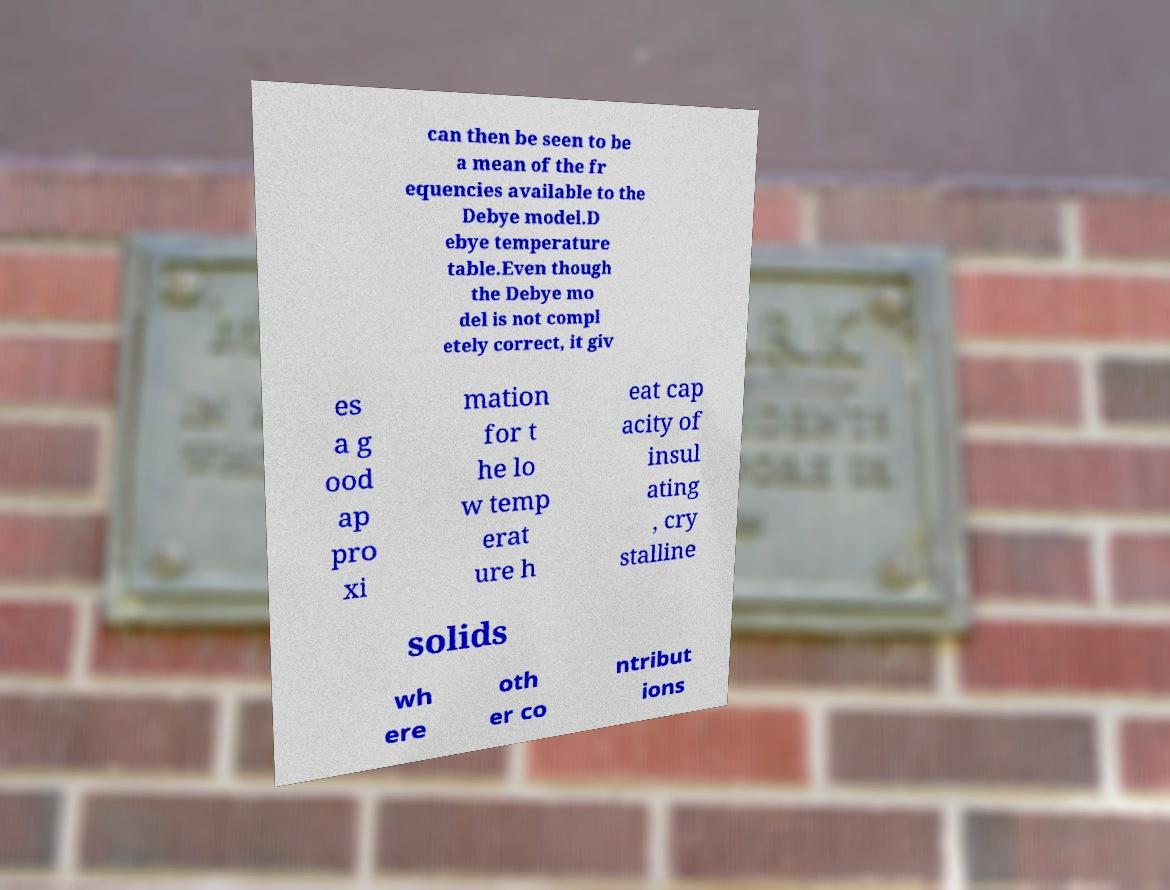For documentation purposes, I need the text within this image transcribed. Could you provide that? can then be seen to be a mean of the fr equencies available to the Debye model.D ebye temperature table.Even though the Debye mo del is not compl etely correct, it giv es a g ood ap pro xi mation for t he lo w temp erat ure h eat cap acity of insul ating , cry stalline solids wh ere oth er co ntribut ions 